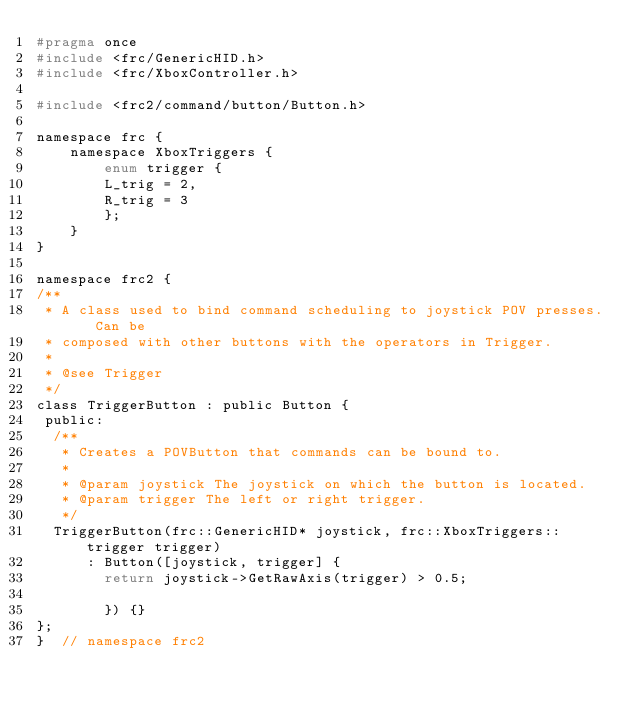<code> <loc_0><loc_0><loc_500><loc_500><_C_>#pragma once
#include <frc/GenericHID.h>
#include <frc/XboxController.h>

#include <frc2/command/button/Button.h>

namespace frc {
    namespace XboxTriggers {
        enum trigger {
        L_trig = 2,
        R_trig = 3
        };
    }
}

namespace frc2 {
/**
 * A class used to bind command scheduling to joystick POV presses.  Can be
 * composed with other buttons with the operators in Trigger.
 *
 * @see Trigger
 */
class TriggerButton : public Button {
 public:
  /**
   * Creates a POVButton that commands can be bound to.
   *
   * @param joystick The joystick on which the button is located.
   * @param trigger The left or right trigger.
   */
  TriggerButton(frc::GenericHID* joystick, frc::XboxTriggers::trigger trigger)
      : Button([joystick, trigger] {
        return joystick->GetRawAxis(trigger) > 0.5;

        }) {}
};
}  // namespace frc2
</code> 